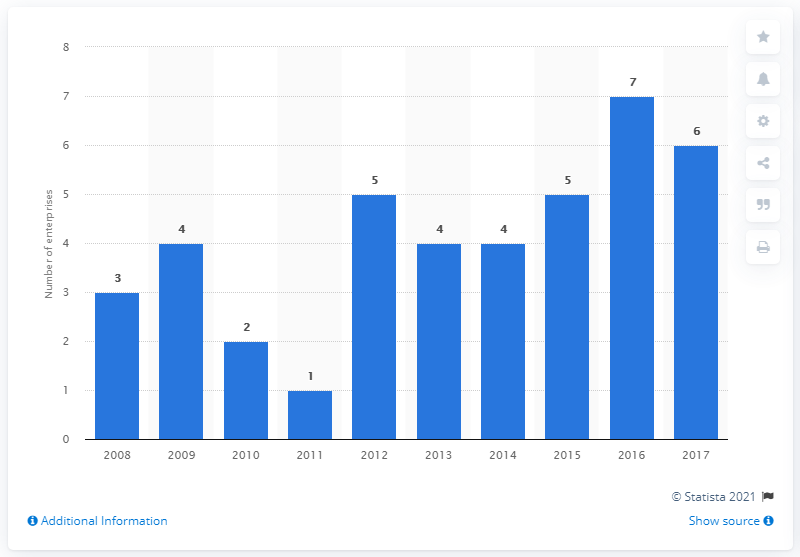How would you describe the trend between 2012 to 2014? Between 2012 and 2014, the histogram shows a stable trend in the number of employees, maintaining a count of 4 for all three years. This suggests a period of stability without significant growth or reduction. What might have caused the stability during that period? Stability in the number of employees over that period could be due to various factors, such as a steady market position, no significant expansions or contractions in the company's workforce, or consistent demand for the company's products or services. 